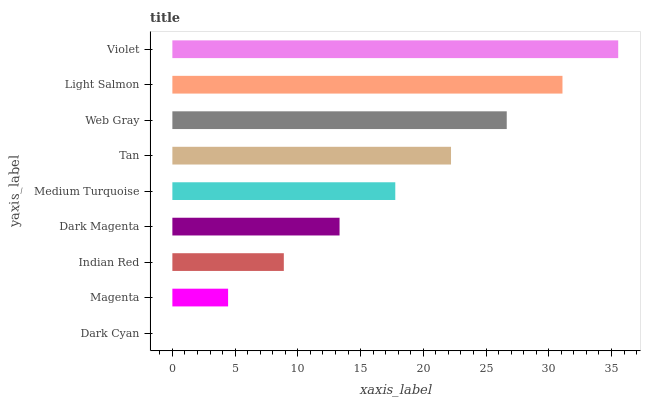Is Dark Cyan the minimum?
Answer yes or no. Yes. Is Violet the maximum?
Answer yes or no. Yes. Is Magenta the minimum?
Answer yes or no. No. Is Magenta the maximum?
Answer yes or no. No. Is Magenta greater than Dark Cyan?
Answer yes or no. Yes. Is Dark Cyan less than Magenta?
Answer yes or no. Yes. Is Dark Cyan greater than Magenta?
Answer yes or no. No. Is Magenta less than Dark Cyan?
Answer yes or no. No. Is Medium Turquoise the high median?
Answer yes or no. Yes. Is Medium Turquoise the low median?
Answer yes or no. Yes. Is Tan the high median?
Answer yes or no. No. Is Web Gray the low median?
Answer yes or no. No. 